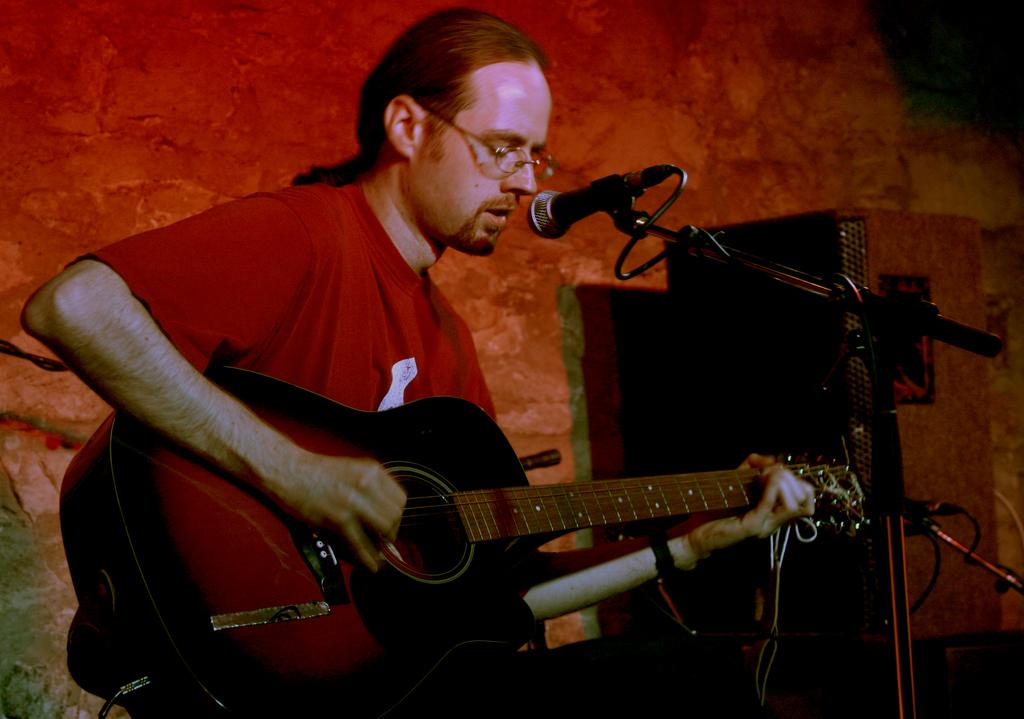What is the man in the image doing? The man is playing a guitar. What object is present in the image that is typically used for amplifying sound? There is a microphone in the image. How many bikes can be seen parked at the edge of the image? There are no bikes present in the image. What is the cent of the guitar in the image? The concept of "cent" does not apply to a guitar, as it is a unit of measurement for angles, not musical instruments. 